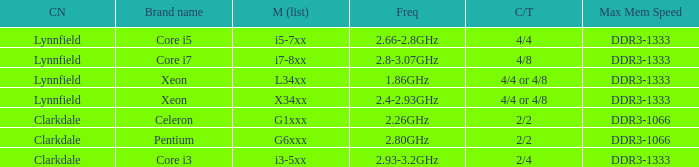List the number of cores for ddr3-1333 with frequencies between 2.66-2.8ghz. 4/4. 